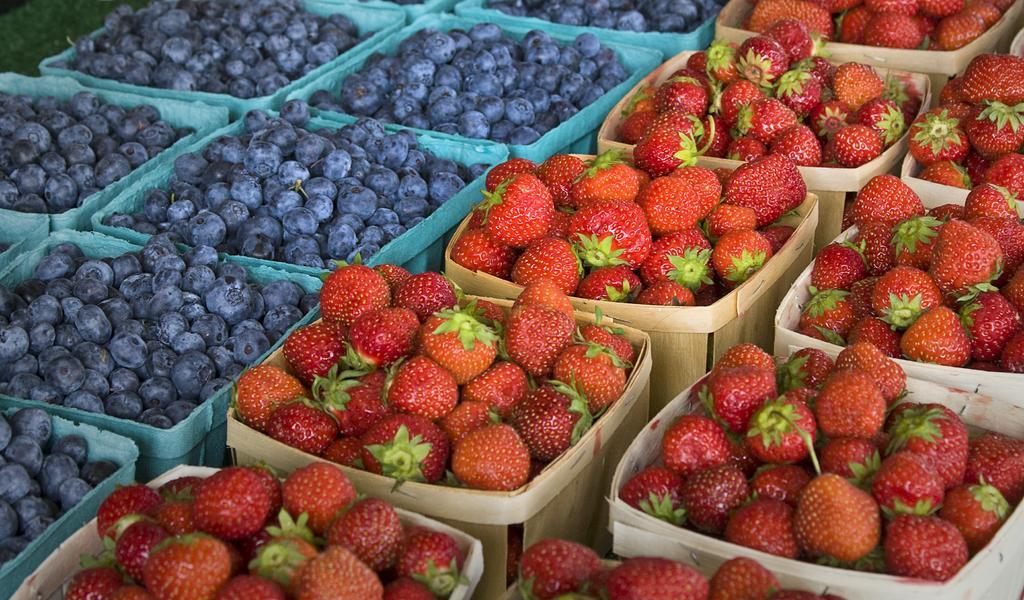How would you summarize this image in a sentence or two? In this image there are baskets full of strawberries on the right side and blue berries on the left side. 